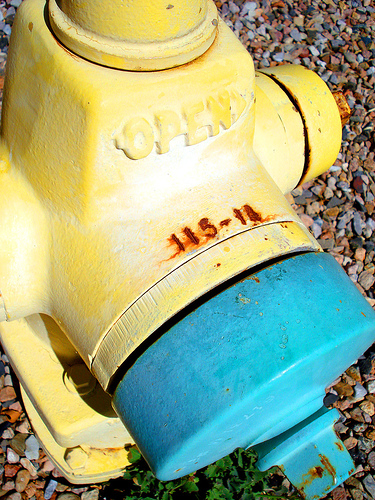<image>
Can you confirm if the rock is behind the hydrant? Yes. From this viewpoint, the rock is positioned behind the hydrant, with the hydrant partially or fully occluding the rock. 